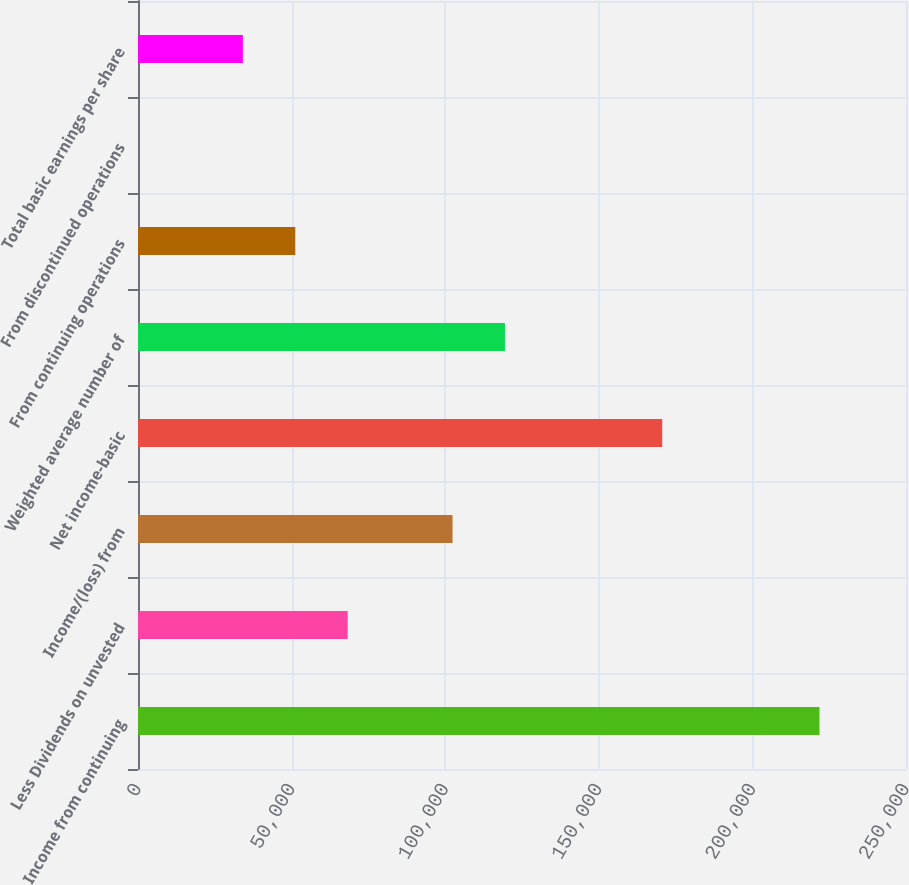Convert chart. <chart><loc_0><loc_0><loc_500><loc_500><bar_chart><fcel>Income from continuing<fcel>Less Dividends on unvested<fcel>Income/(loss) from<fcel>Net income-basic<fcel>Weighted average number of<fcel>From continuing operations<fcel>From discontinued operations<fcel>Total basic earnings per share<nl><fcel>221835<fcel>68256.8<fcel>102385<fcel>170642<fcel>119449<fcel>51192.6<fcel>0.01<fcel>34128.4<nl></chart> 